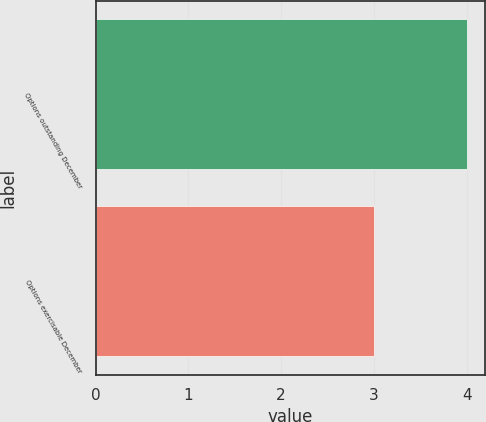<chart> <loc_0><loc_0><loc_500><loc_500><bar_chart><fcel>Options outstanding December<fcel>Options exercisable December<nl><fcel>4<fcel>3<nl></chart> 